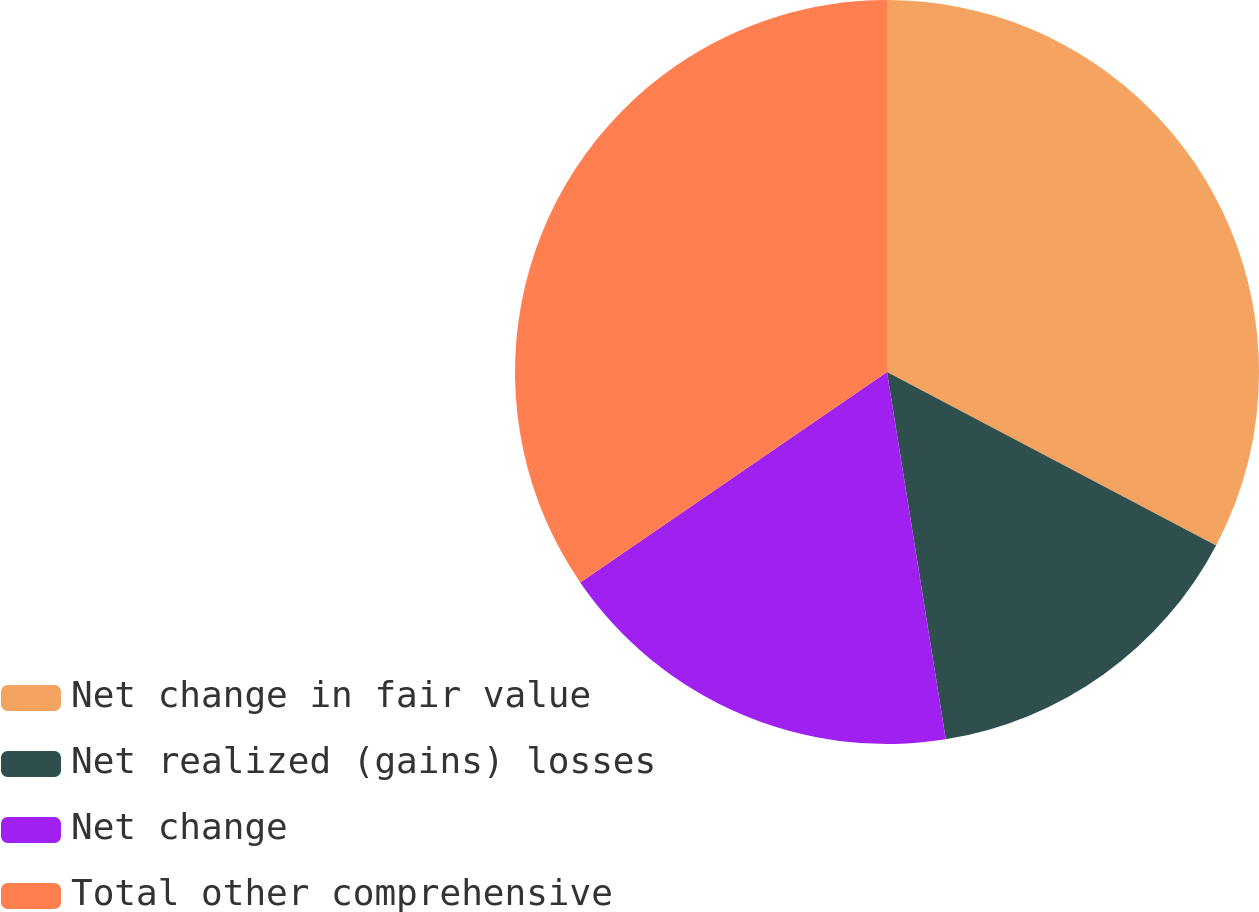Convert chart to OTSL. <chart><loc_0><loc_0><loc_500><loc_500><pie_chart><fcel>Net change in fair value<fcel>Net realized (gains) losses<fcel>Net change<fcel>Total other comprehensive<nl><fcel>32.72%<fcel>14.76%<fcel>17.96%<fcel>34.57%<nl></chart> 